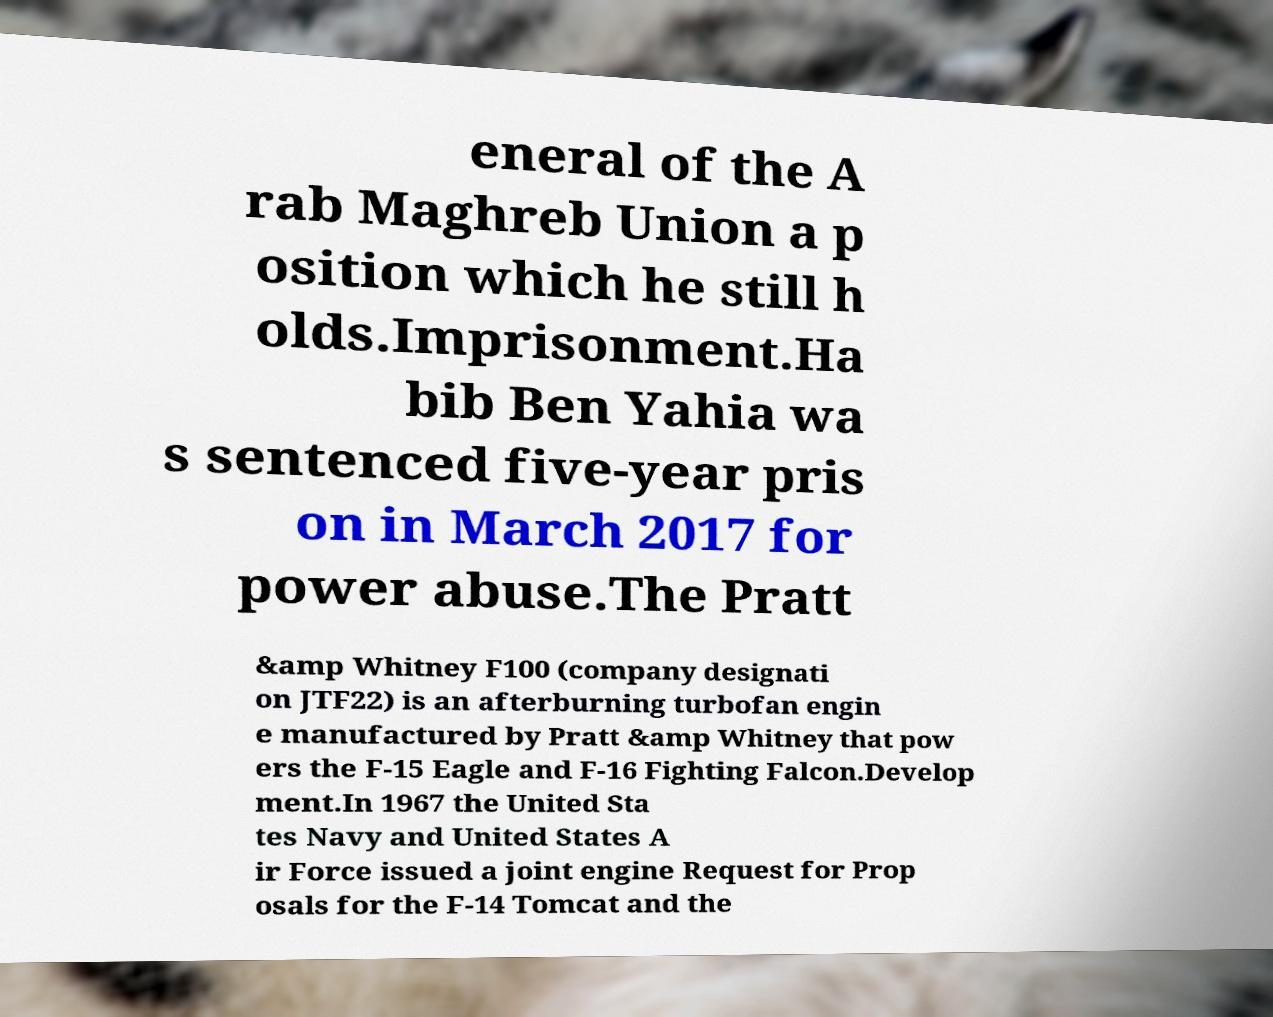Could you extract and type out the text from this image? eneral of the A rab Maghreb Union a p osition which he still h olds.Imprisonment.Ha bib Ben Yahia wa s sentenced five-year pris on in March 2017 for power abuse.The Pratt &amp Whitney F100 (company designati on JTF22) is an afterburning turbofan engin e manufactured by Pratt &amp Whitney that pow ers the F-15 Eagle and F-16 Fighting Falcon.Develop ment.In 1967 the United Sta tes Navy and United States A ir Force issued a joint engine Request for Prop osals for the F-14 Tomcat and the 